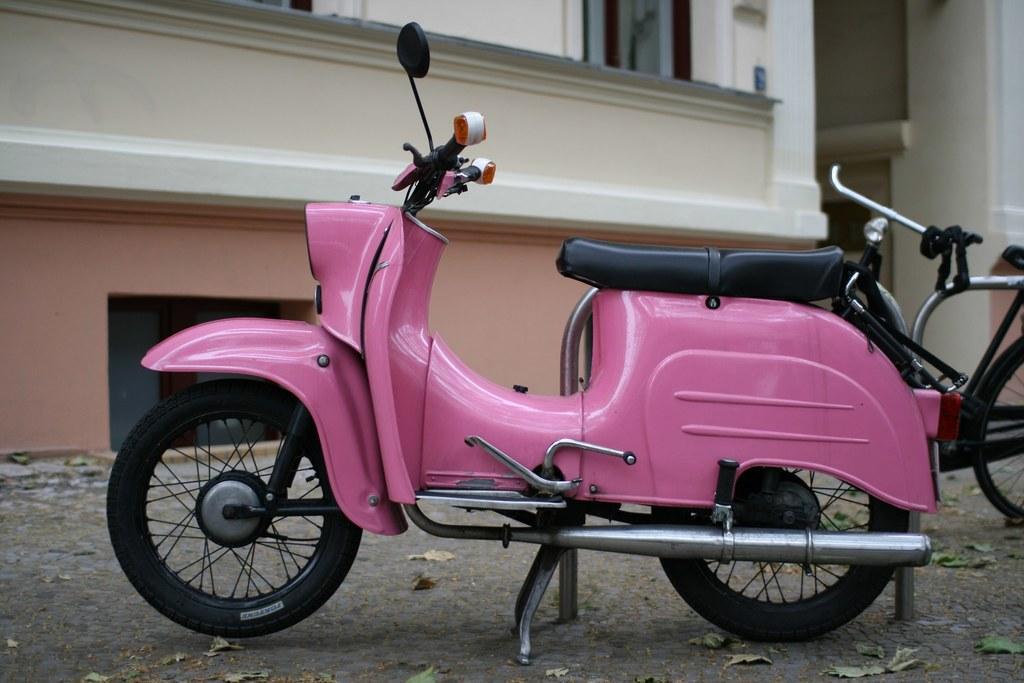Describe this image in one or two sentences. In the center of the image there is a pink color motor bike and behind the motorbike there are bicycles placed on the ground. On the ground there are dried leaves present. In the background there is a building. 